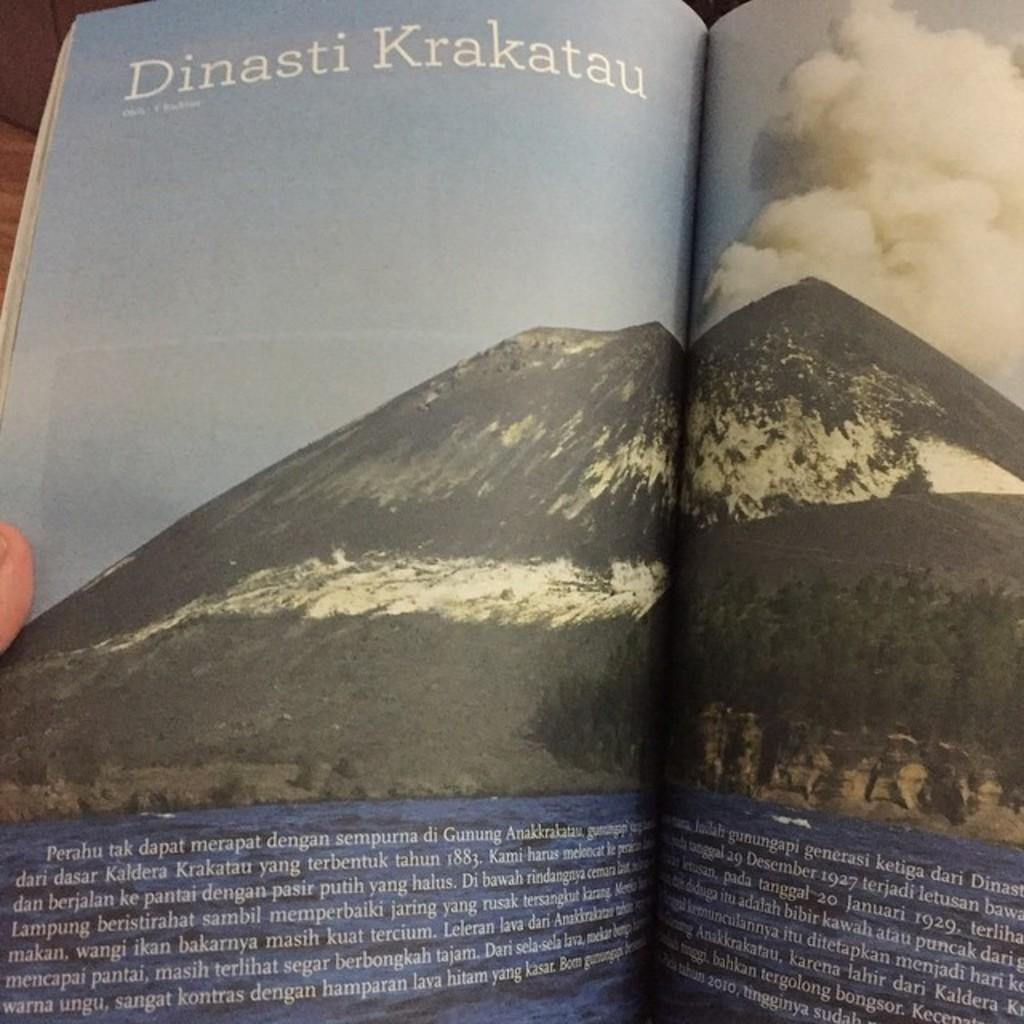<image>
Summarize the visual content of the image. A book opened with a page titled Dinasti Krakatau 